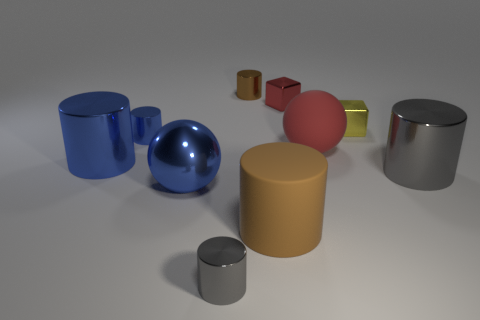There is a small red thing; is it the same shape as the small yellow metallic thing that is behind the brown matte thing?
Provide a short and direct response. Yes. How many other objects are there of the same size as the metal ball?
Offer a very short reply. 4. Is the number of yellow objects greater than the number of blue things?
Provide a short and direct response. No. How many shiny cylinders are both behind the tiny red shiny block and right of the tiny yellow object?
Your answer should be very brief. 0. What shape is the small metallic thing that is on the left side of the large sphere in front of the gray metallic cylinder that is to the right of the big brown matte cylinder?
Ensure brevity in your answer.  Cylinder. How many cylinders are either red objects or small brown metallic objects?
Your answer should be compact. 1. Is the color of the big ball left of the tiny brown object the same as the big rubber cylinder?
Ensure brevity in your answer.  No. There is a big sphere behind the blue metal thing that is in front of the metal cylinder on the right side of the tiny yellow cube; what is it made of?
Provide a short and direct response. Rubber. Do the yellow shiny thing and the red metallic thing have the same size?
Ensure brevity in your answer.  Yes. There is a big matte ball; does it have the same color as the shiny cube that is to the left of the large red rubber thing?
Your answer should be very brief. Yes. 